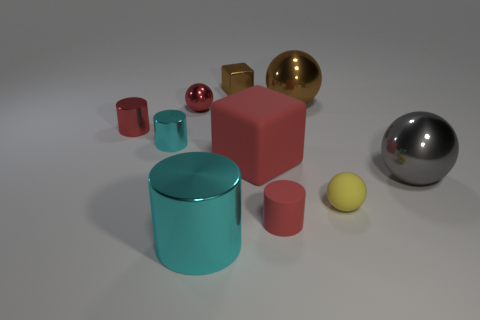There is a metal sphere behind the tiny ball behind the large rubber thing; what color is it?
Keep it short and to the point. Brown. Is there a large object that has the same color as the small block?
Provide a short and direct response. Yes. The rubber object that is the same size as the gray sphere is what color?
Make the answer very short. Red. Is the red cylinder that is behind the gray metallic sphere made of the same material as the yellow thing?
Your answer should be compact. No. Are there any tiny cyan metallic cylinders right of the red metallic cylinder that is on the left side of the large thing that is on the right side of the rubber sphere?
Provide a short and direct response. Yes. There is a cyan shiny thing behind the large metal cylinder; does it have the same shape as the large cyan thing?
Your answer should be very brief. Yes. What is the shape of the tiny brown shiny object that is right of the cyan shiny thing on the left side of the large cyan metallic cylinder?
Keep it short and to the point. Cube. What is the size of the sphere that is on the right side of the small sphere right of the small red object that is in front of the large gray shiny thing?
Give a very brief answer. Large. The large object that is the same shape as the tiny red matte thing is what color?
Make the answer very short. Cyan. Do the yellow object and the gray ball have the same size?
Your answer should be compact. No. 